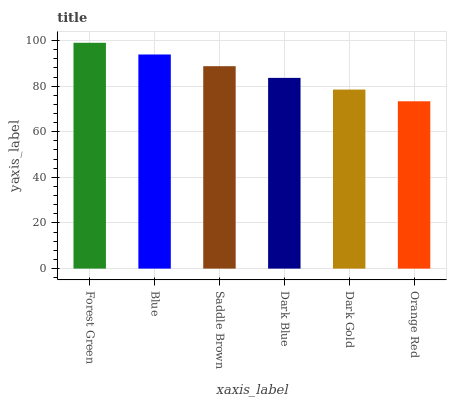Is Orange Red the minimum?
Answer yes or no. Yes. Is Forest Green the maximum?
Answer yes or no. Yes. Is Blue the minimum?
Answer yes or no. No. Is Blue the maximum?
Answer yes or no. No. Is Forest Green greater than Blue?
Answer yes or no. Yes. Is Blue less than Forest Green?
Answer yes or no. Yes. Is Blue greater than Forest Green?
Answer yes or no. No. Is Forest Green less than Blue?
Answer yes or no. No. Is Saddle Brown the high median?
Answer yes or no. Yes. Is Dark Blue the low median?
Answer yes or no. Yes. Is Blue the high median?
Answer yes or no. No. Is Saddle Brown the low median?
Answer yes or no. No. 